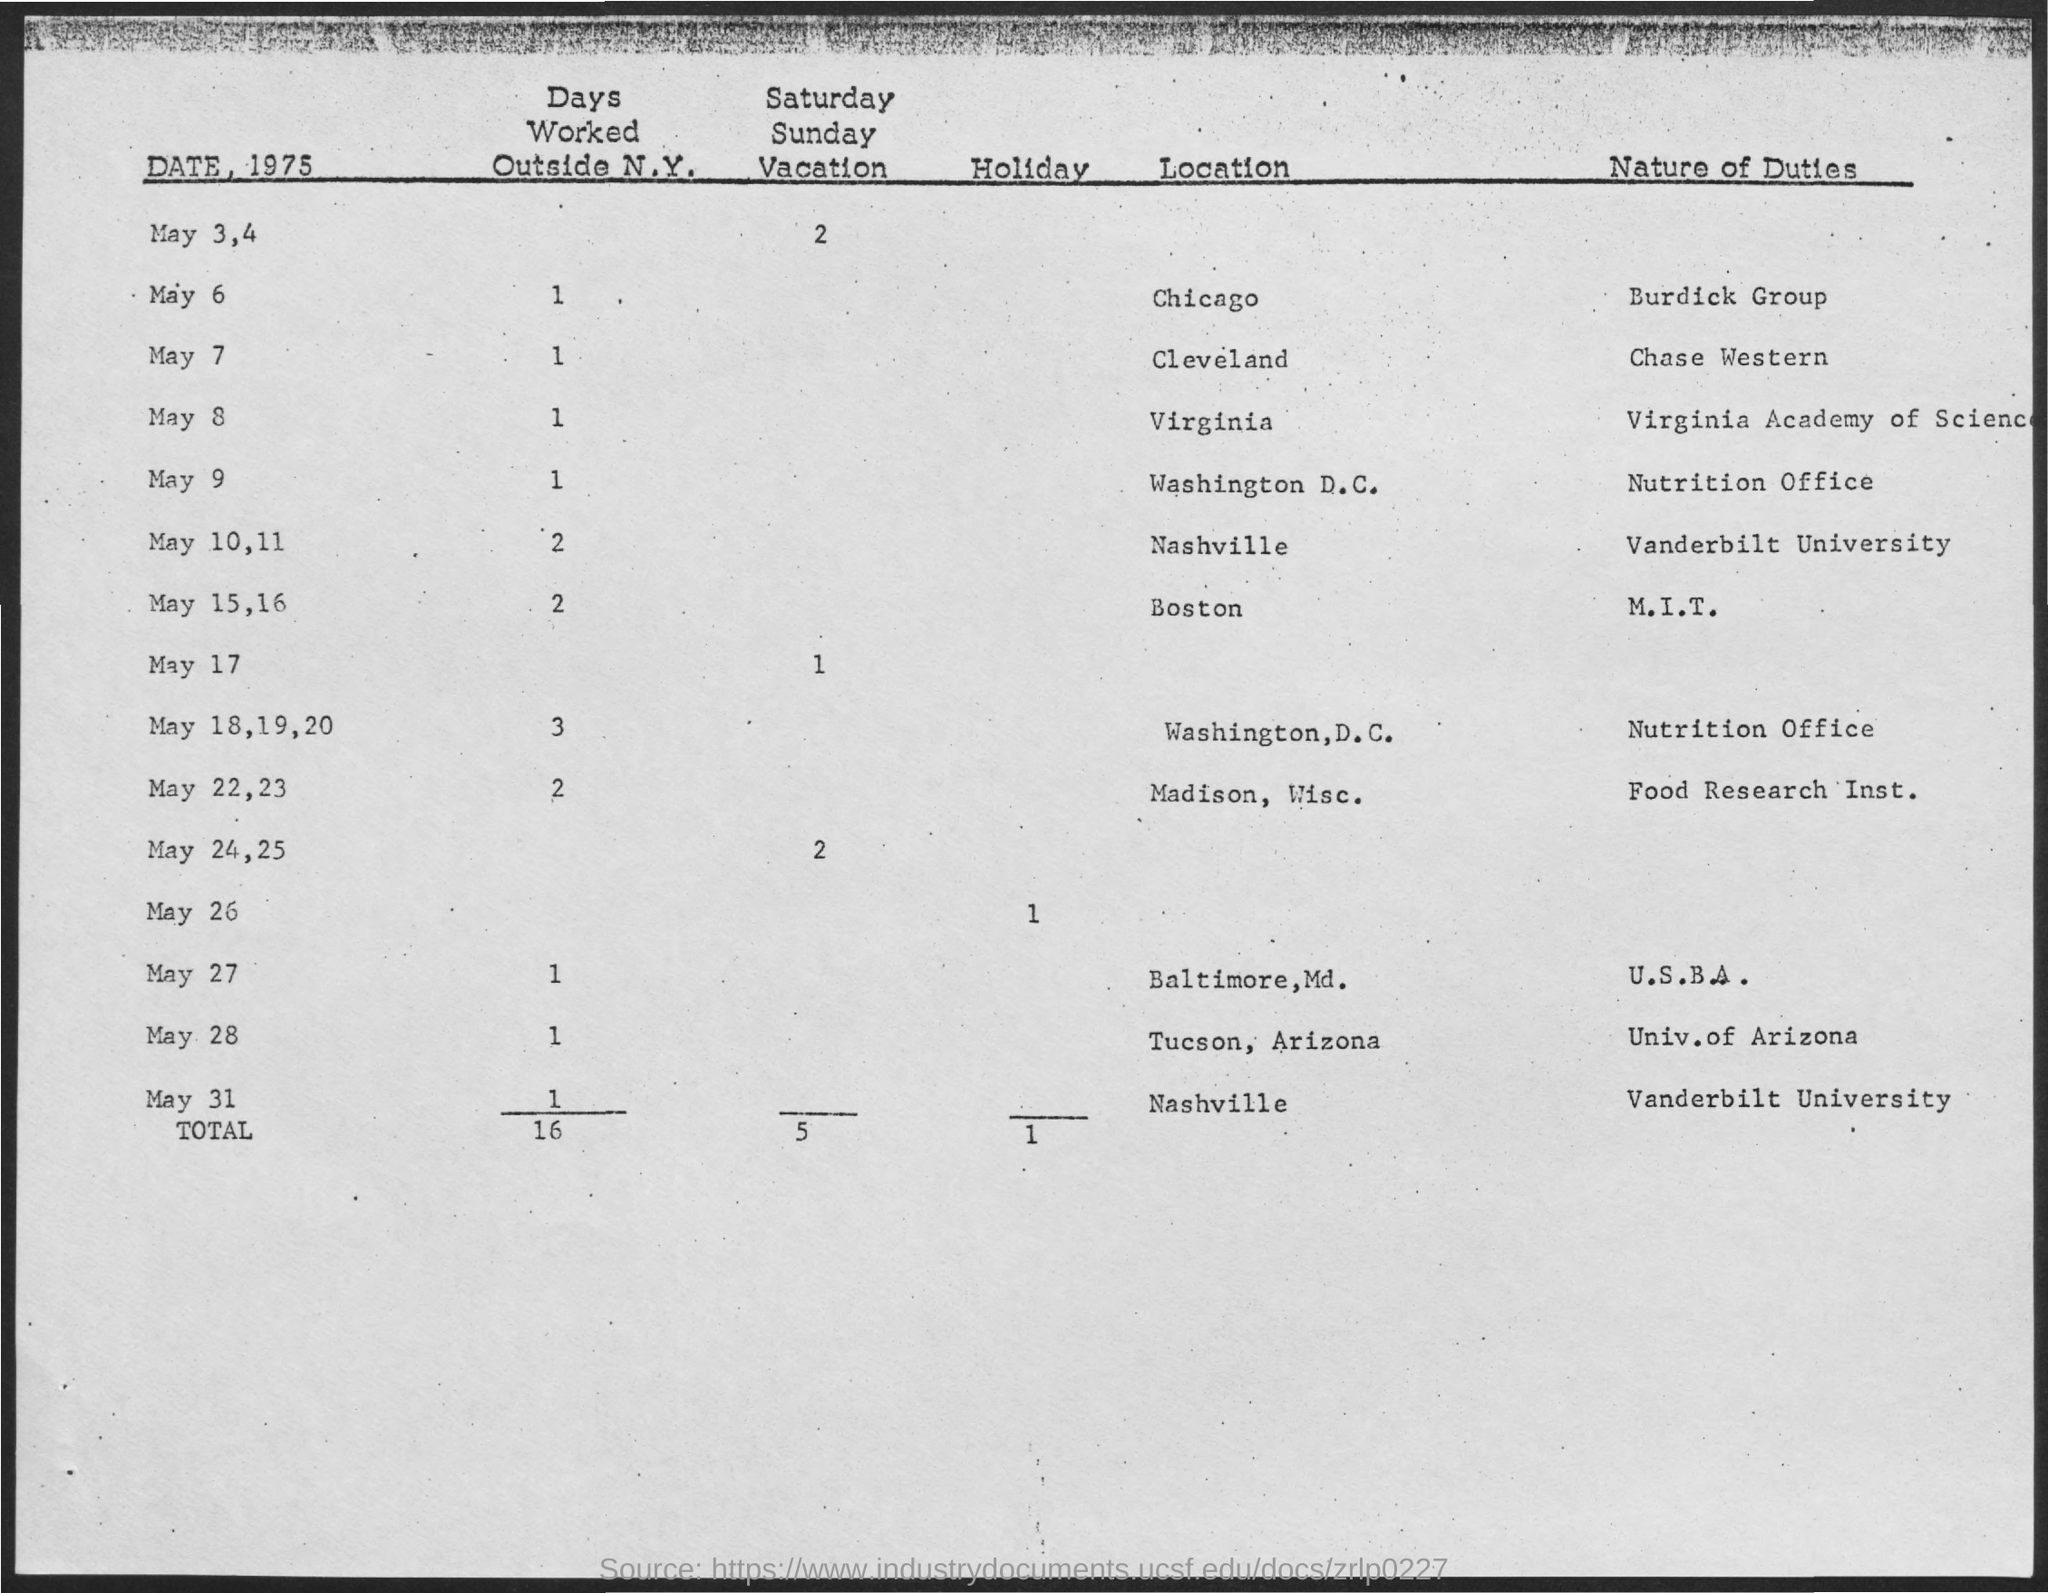What is the total number of days worked outside N.Y.?
Provide a short and direct response. 16. What is the total number of Holidays?
Your response must be concise. 1. What is the nature of duty on May 6?
Ensure brevity in your answer.  Burdick group. What is the nature of duty on May 7?
Give a very brief answer. Chase western. What is the number of days worked outside N.Y. on May 9?
Offer a terse response. 1. What is the number of days worked outside N.Y. on May 28?
Your answer should be compact. 1. What is the number of Saturday-Sunday vacations on May 17?
Offer a terse response. 1. What is the location on May 6?
Your response must be concise. Chicago. What is the location on May 7?
Your answer should be very brief. Cleveland. What is the nature of duty on May 9?
Provide a short and direct response. Nutrition office. 